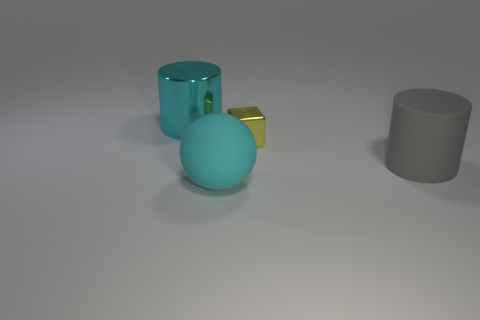Add 3 green rubber blocks. How many objects exist? 7 Subtract all balls. How many objects are left? 3 Subtract all tiny gray matte objects. Subtract all metal blocks. How many objects are left? 3 Add 2 cyan spheres. How many cyan spheres are left? 3 Add 1 large metallic cylinders. How many large metallic cylinders exist? 2 Subtract 0 blue cylinders. How many objects are left? 4 